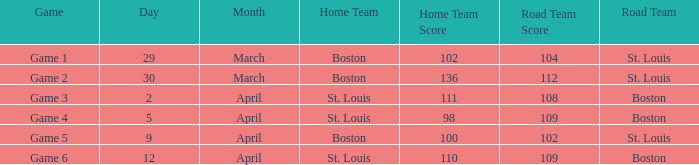Could you help me parse every detail presented in this table? {'header': ['Game', 'Day', 'Month', 'Home Team', 'Home Team Score', 'Road Team Score', 'Road Team'], 'rows': [['Game 1', '29', 'March', 'Boston', '102', '104', 'St. Louis'], ['Game 2', '30', 'March', 'Boston', '136', '112', 'St. Louis'], ['Game 3', '2', 'April', 'St. Louis', '111', '108', 'Boston'], ['Game 4', '5', 'April', 'St. Louis', '98', '109', 'Boston'], ['Game 5', '9', 'April', 'Boston', '100', '102', 'St. Louis'], ['Game 6', '12', 'April', 'St. Louis', '110', '109', 'Boston']]} On what Date is Game 3 with Boston Road Team? April 2. 